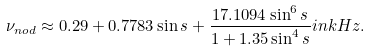Convert formula to latex. <formula><loc_0><loc_0><loc_500><loc_500>\nu _ { n o d } \approx 0 . 2 9 + 0 . 7 7 8 3 \sin { s } + \frac { 1 7 . 1 0 9 4 \sin ^ { 6 } { s } } { 1 + 1 . 3 5 \sin ^ { 4 } { s } } i n k H z .</formula> 